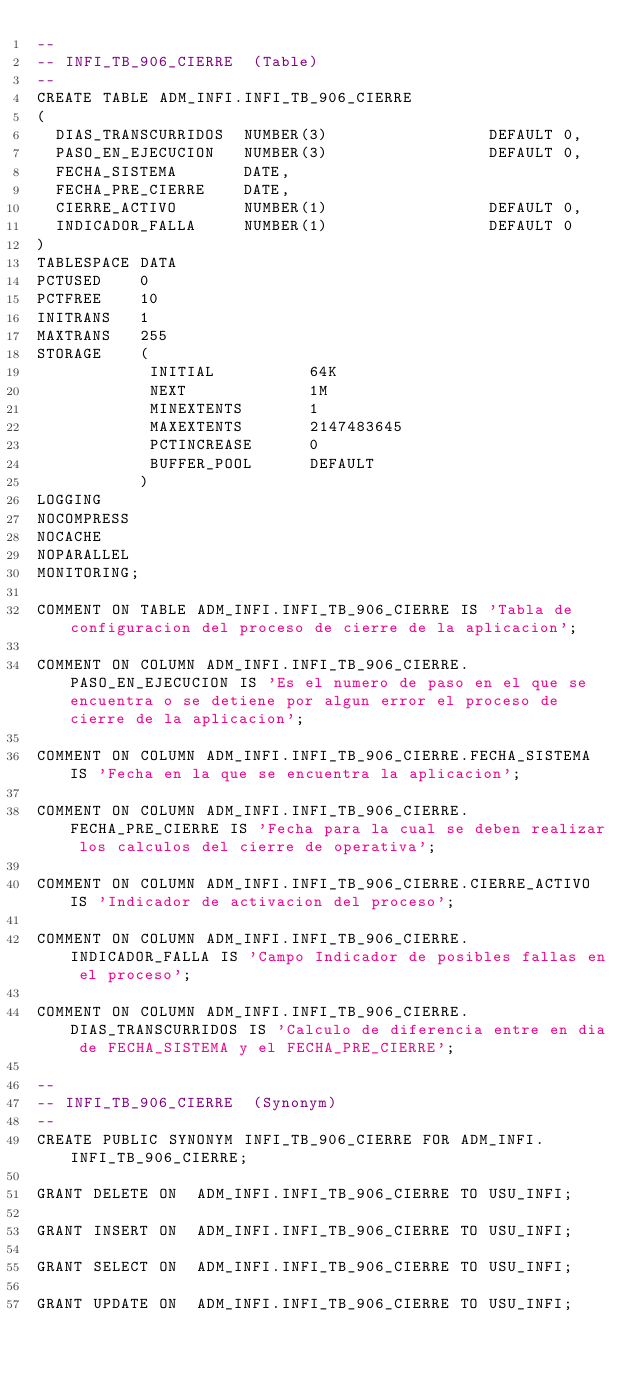Convert code to text. <code><loc_0><loc_0><loc_500><loc_500><_SQL_>--
-- INFI_TB_906_CIERRE  (Table) 
--
CREATE TABLE ADM_INFI.INFI_TB_906_CIERRE
(
  DIAS_TRANSCURRIDOS  NUMBER(3)                 DEFAULT 0,
  PASO_EN_EJECUCION   NUMBER(3)                 DEFAULT 0,
  FECHA_SISTEMA       DATE,
  FECHA_PRE_CIERRE    DATE,
  CIERRE_ACTIVO       NUMBER(1)                 DEFAULT 0,
  INDICADOR_FALLA     NUMBER(1)                 DEFAULT 0
)
TABLESPACE DATA
PCTUSED    0
PCTFREE    10
INITRANS   1
MAXTRANS   255
STORAGE    (
            INITIAL          64K
            NEXT             1M
            MINEXTENTS       1
            MAXEXTENTS       2147483645
            PCTINCREASE      0
            BUFFER_POOL      DEFAULT
           )
LOGGING 
NOCOMPRESS 
NOCACHE
NOPARALLEL
MONITORING;

COMMENT ON TABLE ADM_INFI.INFI_TB_906_CIERRE IS 'Tabla de configuracion del proceso de cierre de la aplicacion';

COMMENT ON COLUMN ADM_INFI.INFI_TB_906_CIERRE.PASO_EN_EJECUCION IS 'Es el numero de paso en el que se encuentra o se detiene por algun error el proceso de cierre de la aplicacion';

COMMENT ON COLUMN ADM_INFI.INFI_TB_906_CIERRE.FECHA_SISTEMA IS 'Fecha en la que se encuentra la aplicacion';

COMMENT ON COLUMN ADM_INFI.INFI_TB_906_CIERRE.FECHA_PRE_CIERRE IS 'Fecha para la cual se deben realizar los calculos del cierre de operativa';

COMMENT ON COLUMN ADM_INFI.INFI_TB_906_CIERRE.CIERRE_ACTIVO IS 'Indicador de activacion del proceso';

COMMENT ON COLUMN ADM_INFI.INFI_TB_906_CIERRE.INDICADOR_FALLA IS 'Campo Indicador de posibles fallas en el proceso';

COMMENT ON COLUMN ADM_INFI.INFI_TB_906_CIERRE.DIAS_TRANSCURRIDOS IS 'Calculo de diferencia entre en dia de FECHA_SISTEMA y el FECHA_PRE_CIERRE';

--
-- INFI_TB_906_CIERRE  (Synonym) 
--
CREATE PUBLIC SYNONYM INFI_TB_906_CIERRE FOR ADM_INFI.INFI_TB_906_CIERRE;

GRANT DELETE ON  ADM_INFI.INFI_TB_906_CIERRE TO USU_INFI;

GRANT INSERT ON  ADM_INFI.INFI_TB_906_CIERRE TO USU_INFI;

GRANT SELECT ON  ADM_INFI.INFI_TB_906_CIERRE TO USU_INFI;

GRANT UPDATE ON  ADM_INFI.INFI_TB_906_CIERRE TO USU_INFI;

</code> 